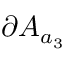<formula> <loc_0><loc_0><loc_500><loc_500>\partial A _ { a _ { 3 } }</formula> 